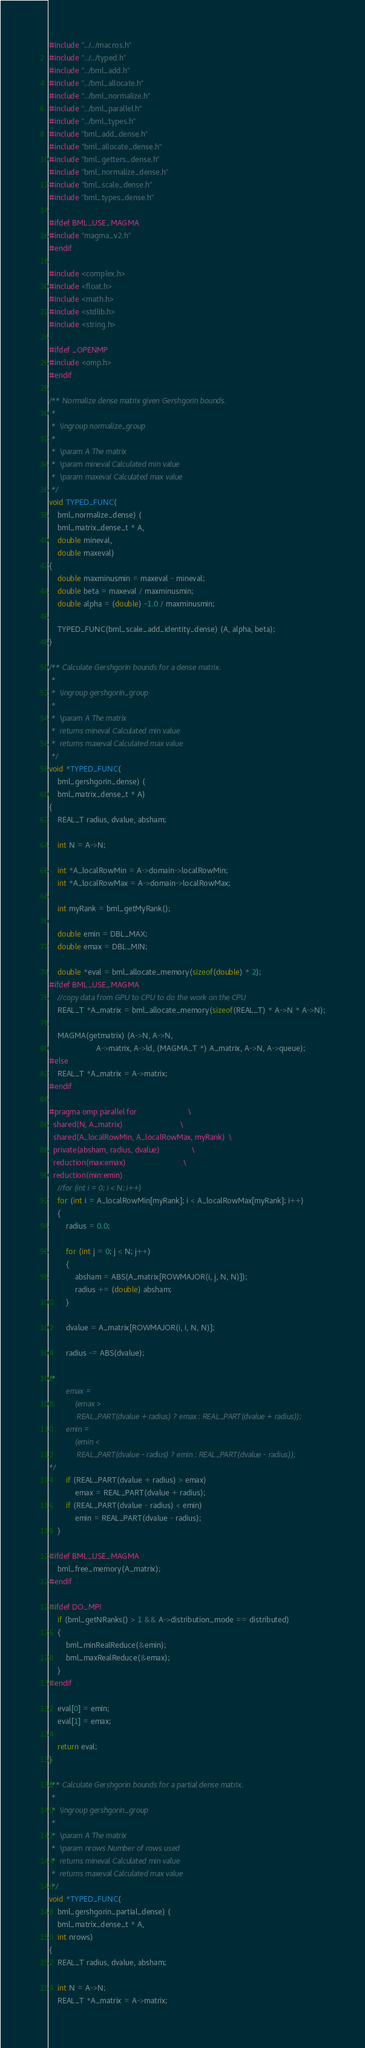<code> <loc_0><loc_0><loc_500><loc_500><_C_>#include "../../macros.h"
#include "../../typed.h"
#include "../bml_add.h"
#include "../bml_allocate.h"
#include "../bml_normalize.h"
#include "../bml_parallel.h"
#include "../bml_types.h"
#include "bml_add_dense.h"
#include "bml_allocate_dense.h"
#include "bml_getters_dense.h"
#include "bml_normalize_dense.h"
#include "bml_scale_dense.h"
#include "bml_types_dense.h"

#ifdef BML_USE_MAGMA
#include "magma_v2.h"
#endif

#include <complex.h>
#include <float.h>
#include <math.h>
#include <stdlib.h>
#include <string.h>

#ifdef _OPENMP
#include <omp.h>
#endif

/** Normalize dense matrix given Gershgorin bounds.
 *
 *  \ingroup normalize_group
 *
 *  \param A The matrix
 *  \param mineval Calculated min value
 *  \param maxeval Calculated max value
 */
void TYPED_FUNC(
    bml_normalize_dense) (
    bml_matrix_dense_t * A,
    double mineval,
    double maxeval)
{
    double maxminusmin = maxeval - mineval;
    double beta = maxeval / maxminusmin;
    double alpha = (double) -1.0 / maxminusmin;

    TYPED_FUNC(bml_scale_add_identity_dense) (A, alpha, beta);
}

/** Calculate Gershgorin bounds for a dense matrix.
 *
 *  \ingroup gershgorin_group
 *
 *  \param A The matrix
 *  returns mineval Calculated min value
 *  returns maxeval Calculated max value
 */
void *TYPED_FUNC(
    bml_gershgorin_dense) (
    bml_matrix_dense_t * A)
{
    REAL_T radius, dvalue, absham;

    int N = A->N;

    int *A_localRowMin = A->domain->localRowMin;
    int *A_localRowMax = A->domain->localRowMax;

    int myRank = bml_getMyRank();

    double emin = DBL_MAX;
    double emax = DBL_MIN;

    double *eval = bml_allocate_memory(sizeof(double) * 2);
#ifdef BML_USE_MAGMA
    //copy data from GPU to CPU to do the work on the CPU
    REAL_T *A_matrix = bml_allocate_memory(sizeof(REAL_T) * A->N * A->N);

    MAGMA(getmatrix) (A->N, A->N,
                      A->matrix, A->ld, (MAGMA_T *) A_matrix, A->N, A->queue);
#else
    REAL_T *A_matrix = A->matrix;
#endif

#pragma omp parallel for                        \
  shared(N, A_matrix)                           \
  shared(A_localRowMin, A_localRowMax, myRank)  \
  private(absham, radius, dvalue)               \
  reduction(max:emax)                           \
  reduction(min:emin)
    //for (int i = 0; i < N; i++)
    for (int i = A_localRowMin[myRank]; i < A_localRowMax[myRank]; i++)
    {
        radius = 0.0;

        for (int j = 0; j < N; j++)
        {
            absham = ABS(A_matrix[ROWMAJOR(i, j, N, N)]);
            radius += (double) absham;
        }

        dvalue = A_matrix[ROWMAJOR(i, i, N, N)];

        radius -= ABS(dvalue);

/*
        emax =
            (emax >
             REAL_PART(dvalue + radius) ? emax : REAL_PART(dvalue + radius));
        emin =
            (emin <
             REAL_PART(dvalue - radius) ? emin : REAL_PART(dvalue - radius));
*/
        if (REAL_PART(dvalue + radius) > emax)
            emax = REAL_PART(dvalue + radius);
        if (REAL_PART(dvalue - radius) < emin)
            emin = REAL_PART(dvalue - radius);
    }

#ifdef BML_USE_MAGMA
    bml_free_memory(A_matrix);
#endif

#ifdef DO_MPI
    if (bml_getNRanks() > 1 && A->distribution_mode == distributed)
    {
        bml_minRealReduce(&emin);
        bml_maxRealReduce(&emax);
    }
#endif

    eval[0] = emin;
    eval[1] = emax;

    return eval;
}

/** Calculate Gershgorin bounds for a partial dense matrix.
 *
 *  \ingroup gershgorin_group
 *
 *  \param A The matrix
 *  \param nrows Number of rows used
 *  returns mineval Calculated min value
 *  returns maxeval Calculated max value
 */
void *TYPED_FUNC(
    bml_gershgorin_partial_dense) (
    bml_matrix_dense_t * A,
    int nrows)
{
    REAL_T radius, dvalue, absham;

    int N = A->N;
    REAL_T *A_matrix = A->matrix;
</code> 